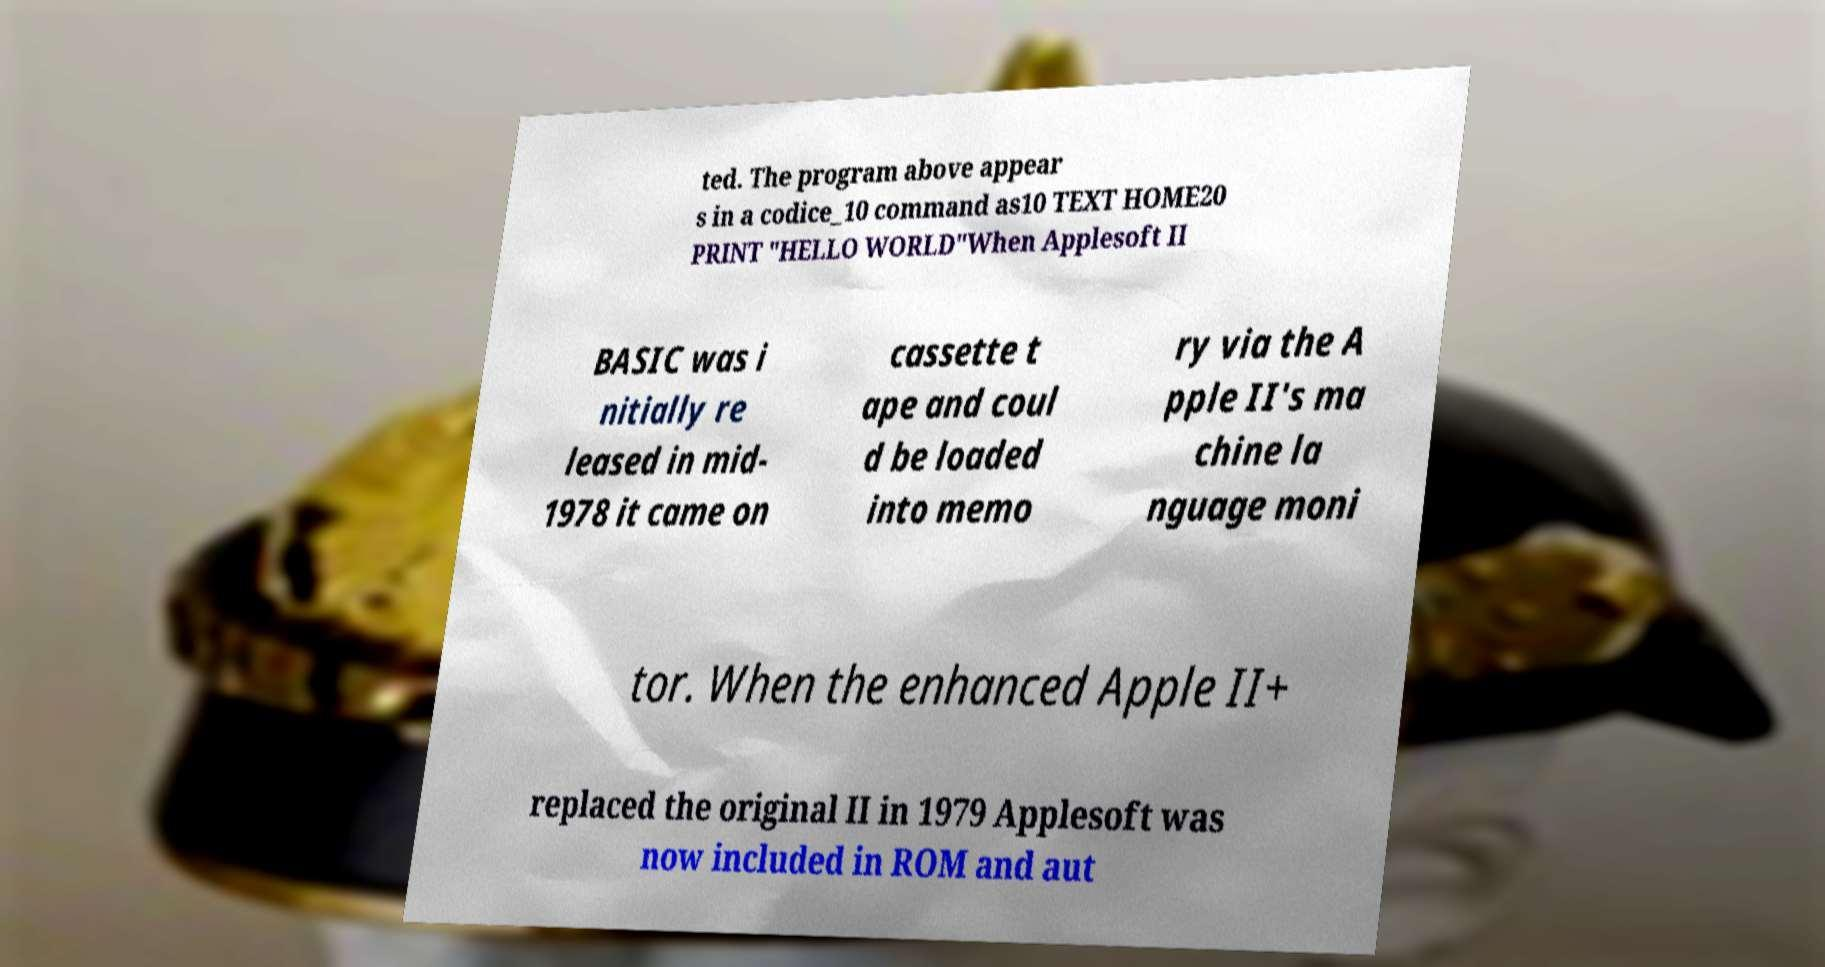Can you read and provide the text displayed in the image?This photo seems to have some interesting text. Can you extract and type it out for me? ted. The program above appear s in a codice_10 command as10 TEXT HOME20 PRINT "HELLO WORLD"When Applesoft II BASIC was i nitially re leased in mid- 1978 it came on cassette t ape and coul d be loaded into memo ry via the A pple II's ma chine la nguage moni tor. When the enhanced Apple II+ replaced the original II in 1979 Applesoft was now included in ROM and aut 